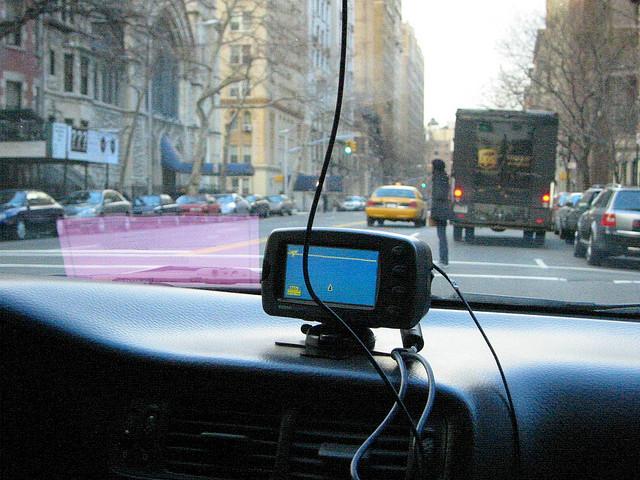Are there any taxis in the scene?
Short answer required. Yes. What GPS system is that?
Be succinct. Garmin. What company owns the black truck?
Write a very short answer. Ups. 